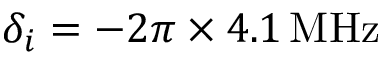<formula> <loc_0><loc_0><loc_500><loc_500>\delta _ { i } = - 2 \pi \times 4 . 1 \, { M H z }</formula> 